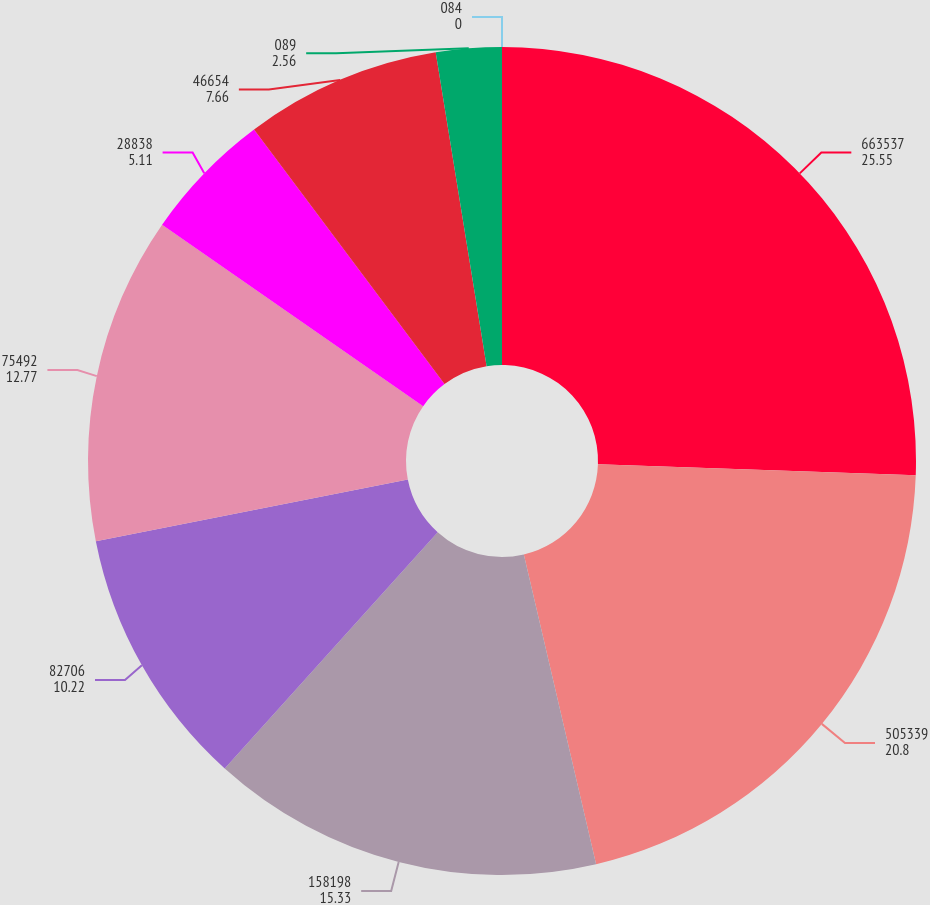Convert chart. <chart><loc_0><loc_0><loc_500><loc_500><pie_chart><fcel>663537<fcel>505339<fcel>158198<fcel>82706<fcel>75492<fcel>28838<fcel>46654<fcel>089<fcel>084<nl><fcel>25.55%<fcel>20.8%<fcel>15.33%<fcel>10.22%<fcel>12.77%<fcel>5.11%<fcel>7.66%<fcel>2.56%<fcel>0.0%<nl></chart> 